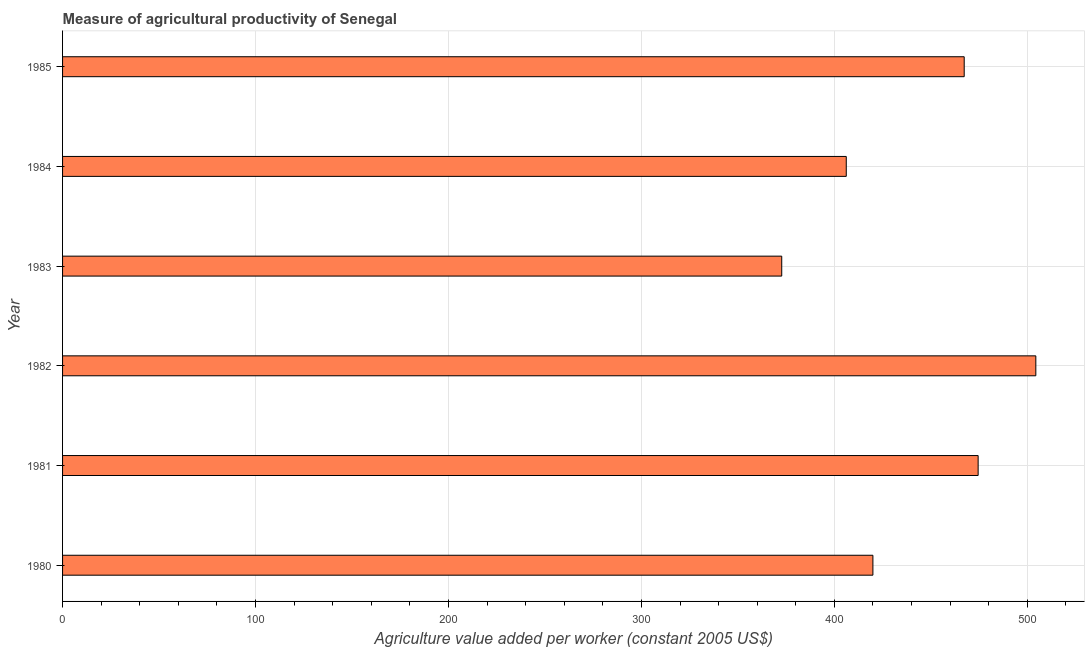Does the graph contain any zero values?
Make the answer very short. No. Does the graph contain grids?
Provide a short and direct response. Yes. What is the title of the graph?
Make the answer very short. Measure of agricultural productivity of Senegal. What is the label or title of the X-axis?
Offer a very short reply. Agriculture value added per worker (constant 2005 US$). What is the label or title of the Y-axis?
Your answer should be very brief. Year. What is the agriculture value added per worker in 1981?
Give a very brief answer. 474.51. Across all years, what is the maximum agriculture value added per worker?
Your answer should be compact. 504.4. Across all years, what is the minimum agriculture value added per worker?
Offer a terse response. 372.72. In which year was the agriculture value added per worker minimum?
Give a very brief answer. 1983. What is the sum of the agriculture value added per worker?
Your answer should be compact. 2645.05. What is the difference between the agriculture value added per worker in 1980 and 1983?
Your answer should be compact. 47.25. What is the average agriculture value added per worker per year?
Keep it short and to the point. 440.84. What is the median agriculture value added per worker?
Give a very brief answer. 443.63. What is the ratio of the agriculture value added per worker in 1980 to that in 1983?
Offer a very short reply. 1.13. Is the difference between the agriculture value added per worker in 1980 and 1983 greater than the difference between any two years?
Provide a short and direct response. No. What is the difference between the highest and the second highest agriculture value added per worker?
Make the answer very short. 29.9. What is the difference between the highest and the lowest agriculture value added per worker?
Keep it short and to the point. 131.68. In how many years, is the agriculture value added per worker greater than the average agriculture value added per worker taken over all years?
Offer a very short reply. 3. Are all the bars in the graph horizontal?
Offer a terse response. Yes. What is the Agriculture value added per worker (constant 2005 US$) in 1980?
Give a very brief answer. 419.97. What is the Agriculture value added per worker (constant 2005 US$) in 1981?
Offer a terse response. 474.51. What is the Agriculture value added per worker (constant 2005 US$) of 1982?
Offer a terse response. 504.4. What is the Agriculture value added per worker (constant 2005 US$) of 1983?
Offer a very short reply. 372.72. What is the Agriculture value added per worker (constant 2005 US$) of 1984?
Your answer should be compact. 406.16. What is the Agriculture value added per worker (constant 2005 US$) in 1985?
Your answer should be compact. 467.29. What is the difference between the Agriculture value added per worker (constant 2005 US$) in 1980 and 1981?
Make the answer very short. -54.54. What is the difference between the Agriculture value added per worker (constant 2005 US$) in 1980 and 1982?
Provide a succinct answer. -84.44. What is the difference between the Agriculture value added per worker (constant 2005 US$) in 1980 and 1983?
Your answer should be compact. 47.25. What is the difference between the Agriculture value added per worker (constant 2005 US$) in 1980 and 1984?
Provide a succinct answer. 13.81. What is the difference between the Agriculture value added per worker (constant 2005 US$) in 1980 and 1985?
Keep it short and to the point. -47.32. What is the difference between the Agriculture value added per worker (constant 2005 US$) in 1981 and 1982?
Make the answer very short. -29.9. What is the difference between the Agriculture value added per worker (constant 2005 US$) in 1981 and 1983?
Give a very brief answer. 101.79. What is the difference between the Agriculture value added per worker (constant 2005 US$) in 1981 and 1984?
Offer a terse response. 68.35. What is the difference between the Agriculture value added per worker (constant 2005 US$) in 1981 and 1985?
Your answer should be compact. 7.22. What is the difference between the Agriculture value added per worker (constant 2005 US$) in 1982 and 1983?
Offer a very short reply. 131.68. What is the difference between the Agriculture value added per worker (constant 2005 US$) in 1982 and 1984?
Give a very brief answer. 98.24. What is the difference between the Agriculture value added per worker (constant 2005 US$) in 1982 and 1985?
Your answer should be compact. 37.12. What is the difference between the Agriculture value added per worker (constant 2005 US$) in 1983 and 1984?
Give a very brief answer. -33.44. What is the difference between the Agriculture value added per worker (constant 2005 US$) in 1983 and 1985?
Provide a short and direct response. -94.57. What is the difference between the Agriculture value added per worker (constant 2005 US$) in 1984 and 1985?
Keep it short and to the point. -61.12. What is the ratio of the Agriculture value added per worker (constant 2005 US$) in 1980 to that in 1981?
Your answer should be compact. 0.89. What is the ratio of the Agriculture value added per worker (constant 2005 US$) in 1980 to that in 1982?
Give a very brief answer. 0.83. What is the ratio of the Agriculture value added per worker (constant 2005 US$) in 1980 to that in 1983?
Offer a very short reply. 1.13. What is the ratio of the Agriculture value added per worker (constant 2005 US$) in 1980 to that in 1984?
Keep it short and to the point. 1.03. What is the ratio of the Agriculture value added per worker (constant 2005 US$) in 1980 to that in 1985?
Offer a terse response. 0.9. What is the ratio of the Agriculture value added per worker (constant 2005 US$) in 1981 to that in 1982?
Provide a succinct answer. 0.94. What is the ratio of the Agriculture value added per worker (constant 2005 US$) in 1981 to that in 1983?
Keep it short and to the point. 1.27. What is the ratio of the Agriculture value added per worker (constant 2005 US$) in 1981 to that in 1984?
Your answer should be compact. 1.17. What is the ratio of the Agriculture value added per worker (constant 2005 US$) in 1981 to that in 1985?
Your answer should be compact. 1.01. What is the ratio of the Agriculture value added per worker (constant 2005 US$) in 1982 to that in 1983?
Your answer should be very brief. 1.35. What is the ratio of the Agriculture value added per worker (constant 2005 US$) in 1982 to that in 1984?
Your response must be concise. 1.24. What is the ratio of the Agriculture value added per worker (constant 2005 US$) in 1982 to that in 1985?
Keep it short and to the point. 1.08. What is the ratio of the Agriculture value added per worker (constant 2005 US$) in 1983 to that in 1984?
Provide a succinct answer. 0.92. What is the ratio of the Agriculture value added per worker (constant 2005 US$) in 1983 to that in 1985?
Provide a succinct answer. 0.8. What is the ratio of the Agriculture value added per worker (constant 2005 US$) in 1984 to that in 1985?
Ensure brevity in your answer.  0.87. 